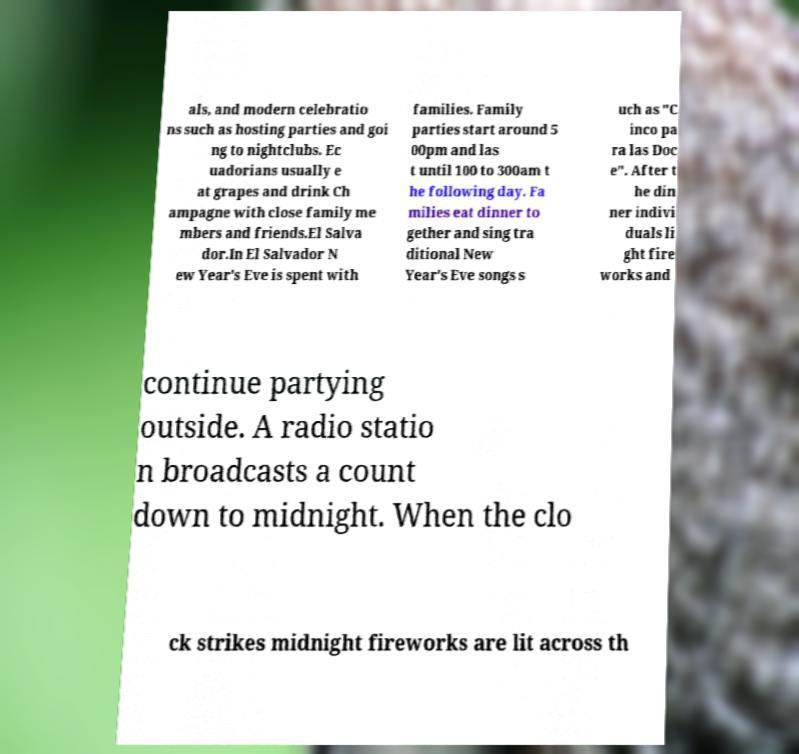Please identify and transcribe the text found in this image. als, and modern celebratio ns such as hosting parties and goi ng to nightclubs. Ec uadorians usually e at grapes and drink Ch ampagne with close family me mbers and friends.El Salva dor.In El Salvador N ew Year's Eve is spent with families. Family parties start around 5 00pm and las t until 100 to 300am t he following day. Fa milies eat dinner to gether and sing tra ditional New Year's Eve songs s uch as "C inco pa ra las Doc e". After t he din ner indivi duals li ght fire works and continue partying outside. A radio statio n broadcasts a count down to midnight. When the clo ck strikes midnight fireworks are lit across th 